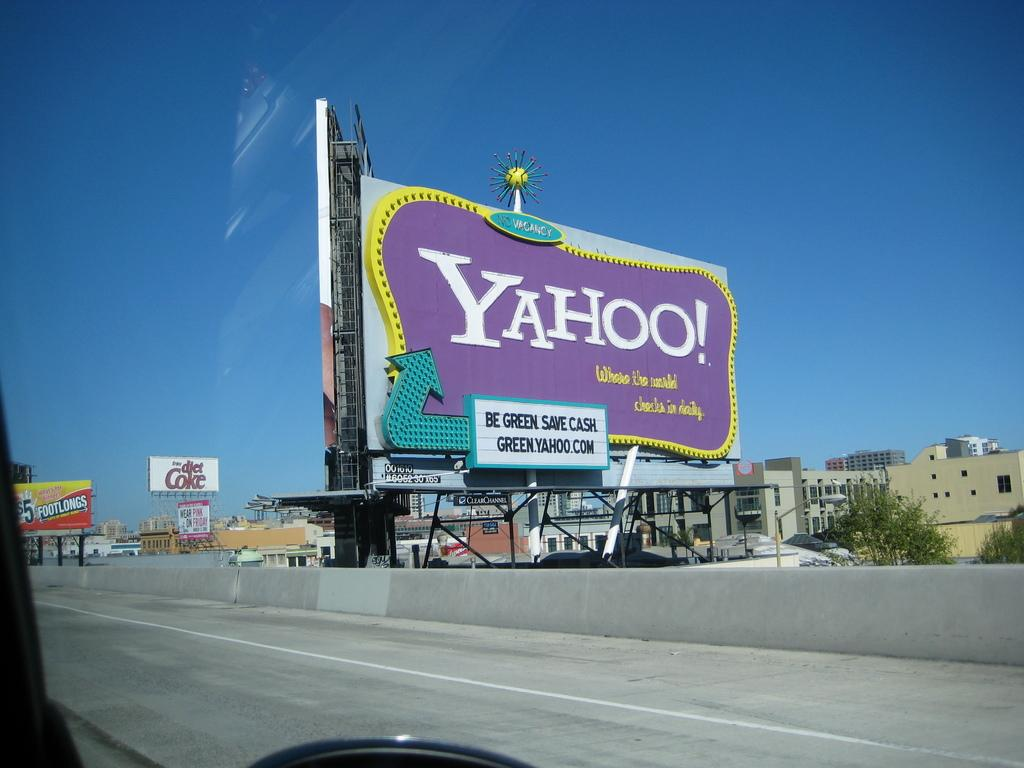<image>
Offer a succinct explanation of the picture presented. A large purple billboard advertising for Yahoo and being green. 